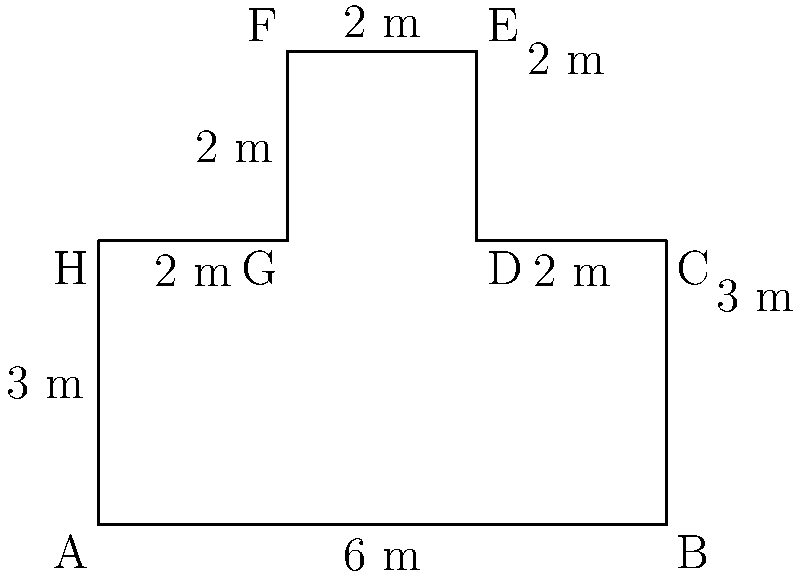As a savvy businesswoman, you're planning a new conference room for your company's headquarters in Edinburgh. The architect has designed an irregularly shaped room to maximize space efficiency. Given the floor plan shown above with the measurements in meters, calculate the perimeter of the conference room. How many meters of skirting board will you need to order to go around the entire room? To calculate the perimeter of the irregularly shaped conference room, we need to sum up the lengths of all sides:

1. Bottom side (AB): 6 m
2. Right side (BC): 3 m
3. Top-right side (CD): 2 m
4. Right side (DE): 2 m
5. Top side (EF): 2 m
6. Left side (FG): 2 m
7. Bottom-left side (GH): 2 m
8. Left side (HA): 3 m

Now, let's add all these lengths:

$$\text{Perimeter} = 6 + 3 + 2 + 2 + 2 + 2 + 2 + 3 = 22\text{ m}$$

Therefore, the perimeter of the conference room is 22 meters, which is the amount of skirting board needed to go around the entire room.
Answer: 22 m 